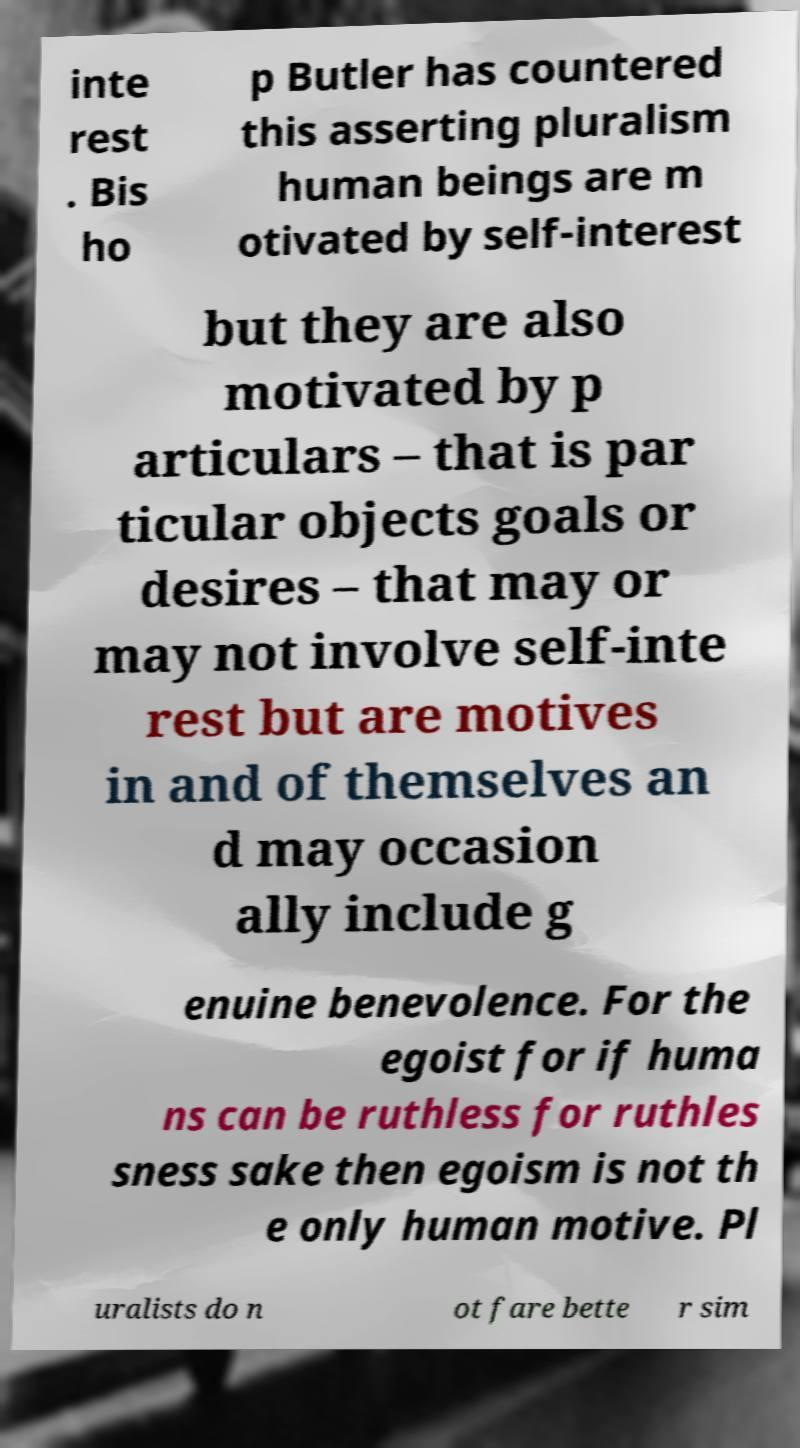There's text embedded in this image that I need extracted. Can you transcribe it verbatim? inte rest . Bis ho p Butler has countered this asserting pluralism human beings are m otivated by self-interest but they are also motivated by p articulars – that is par ticular objects goals or desires – that may or may not involve self-inte rest but are motives in and of themselves an d may occasion ally include g enuine benevolence. For the egoist for if huma ns can be ruthless for ruthles sness sake then egoism is not th e only human motive. Pl uralists do n ot fare bette r sim 